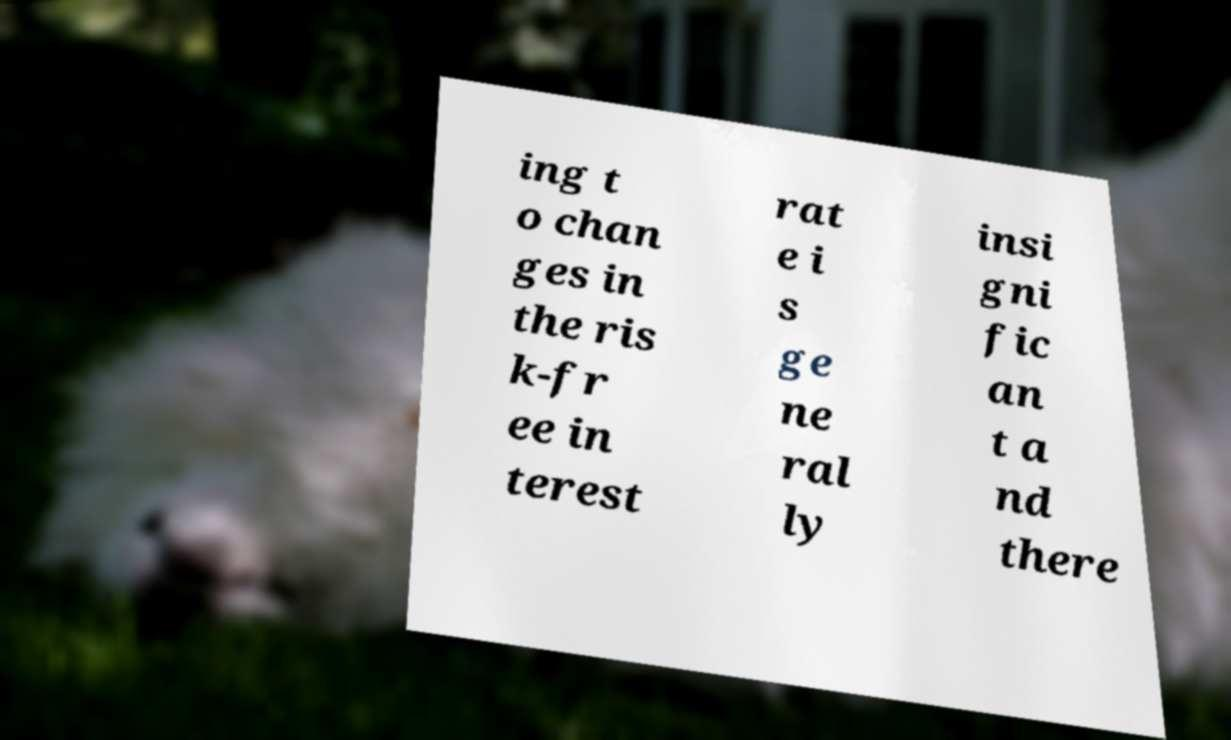There's text embedded in this image that I need extracted. Can you transcribe it verbatim? ing t o chan ges in the ris k-fr ee in terest rat e i s ge ne ral ly insi gni fic an t a nd there 